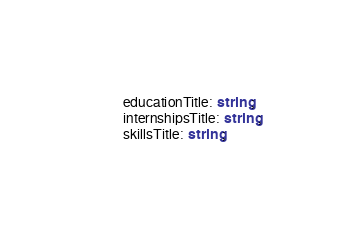Convert code to text. <code><loc_0><loc_0><loc_500><loc_500><_TypeScript_>        educationTitle: string;
        internshipsTitle: string;
        skillsTitle: string;</code> 